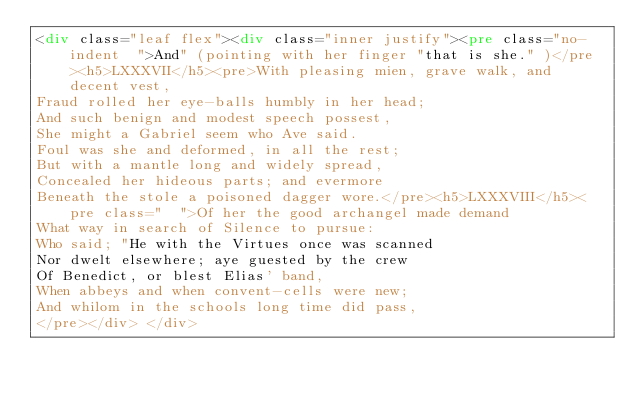Convert code to text. <code><loc_0><loc_0><loc_500><loc_500><_HTML_><div class="leaf flex"><div class="inner justify"><pre class="no-indent  ">And" (pointing with her finger "that is she." )</pre><h5>LXXXVII</h5><pre>With pleasing mien, grave walk, and decent vest,
Fraud rolled her eye-balls humbly in her head;
And such benign and modest speech possest,
She might a Gabriel seem who Ave said.
Foul was she and deformed, in all the rest;
But with a mantle long and widely spread,
Concealed her hideous parts; and evermore
Beneath the stole a poisoned dagger wore.</pre><h5>LXXXVIII</h5><pre class="  ">Of her the good archangel made demand
What way in search of Silence to pursue:
Who said; "He with the Virtues once was scanned
Nor dwelt elsewhere; aye guested by the crew
Of Benedict, or blest Elias' band,
When abbeys and when convent-cells were new;
And whilom in the schools long time did pass,
</pre></div> </div></code> 